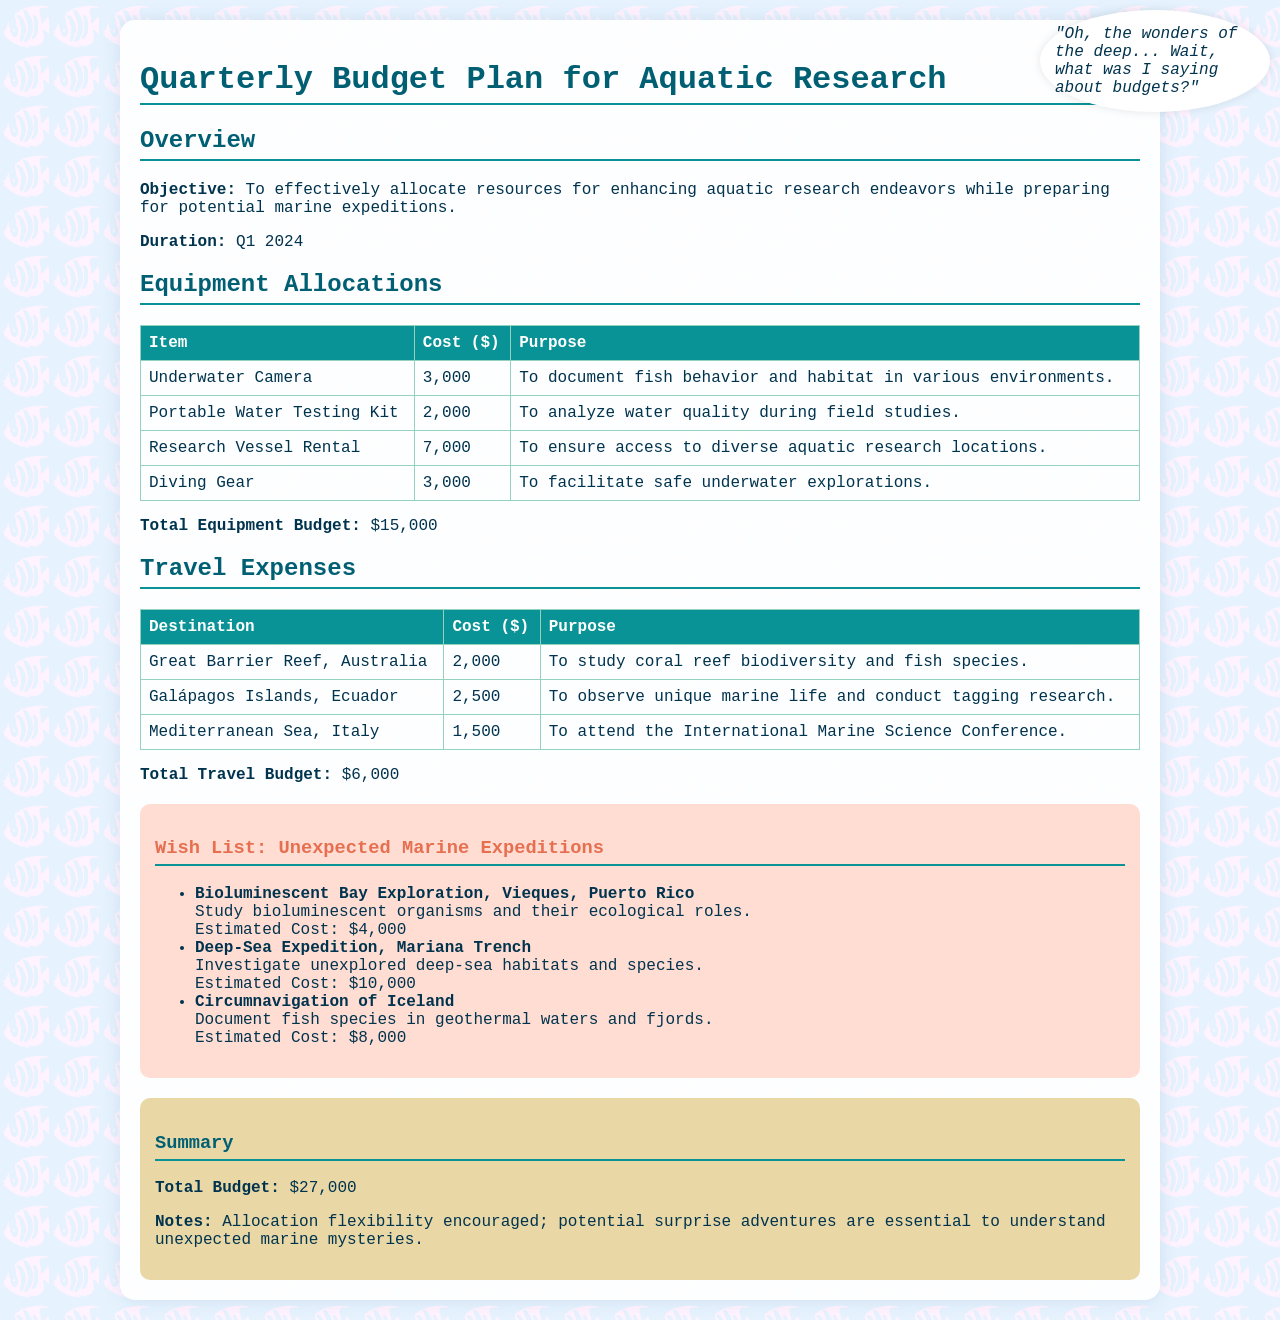what is the total equipment budget? The total equipment budget is the sum of all equipment allocations listed, which is $3,000 + $2,000 + $7,000 + $3,000 = $15,000.
Answer: $15,000 what is the estimated cost for the Deep-Sea Expedition? The estimated cost for the Deep-Sea Expedition is listed explicitly in the wish list section.
Answer: $10,000 how many destinations are listed under travel expenses? The document lists three specific destinations under travel expenses, which are Great Barrier Reef, Galápagos Islands, and Mediterranean Sea.
Answer: three what is the purpose of the Portable Water Testing Kit? The purpose of the Portable Water Testing Kit is described in the equipment allocations table.
Answer: To analyze water quality during field studies what is the total budget for the quarterly plan? The total budget is the sum of all allocations, which is $15,000 for equipment plus $6,000 for travel and $6,000 for the wish list, giving a total of $27,000.
Answer: $27,000 what is the purpose of the Great Barrier Reef trip? The purpose of the trip to the Great Barrier Reef is mentioned in the travel expenses section.
Answer: To study coral reef biodiversity and fish species how much is allocated for the Bioluminescent Bay Exploration? The allocated amount for the Bioluminescent Bay Exploration is detailed in the wish list section.
Answer: $4,000 what is the title of the document? The title of the document is found in the header section.
Answer: Quarterly Budget Plan for Aquatic Research 